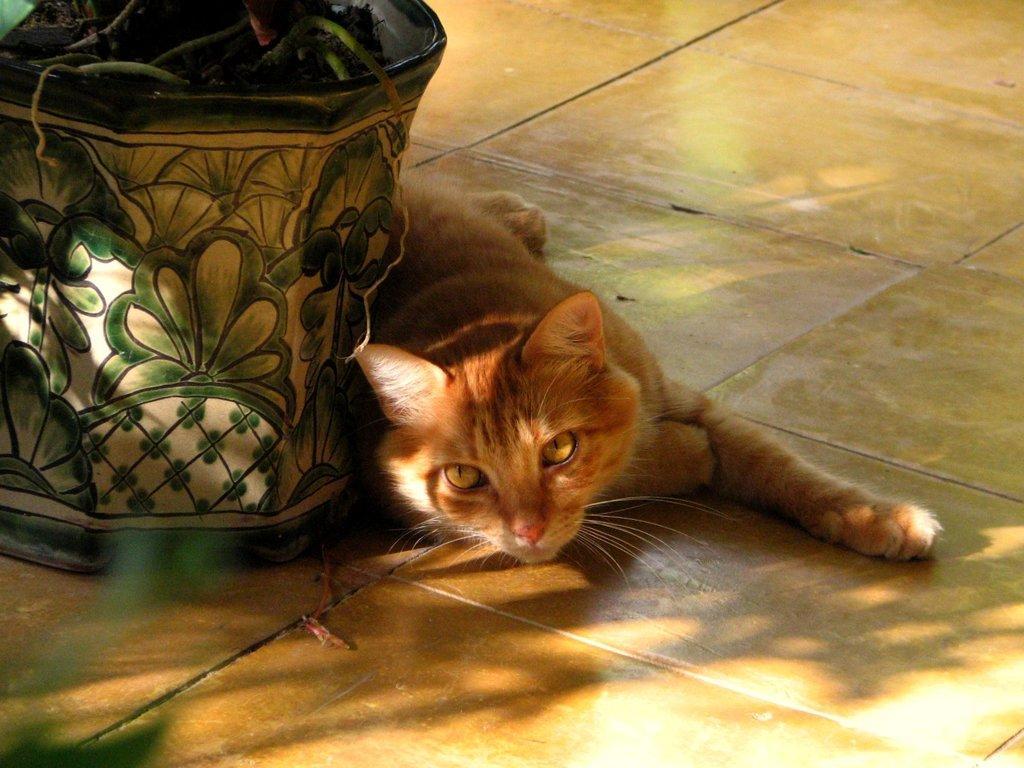Could you give a brief overview of what you see in this image? In the center of the image we can see a cat on the floor. We can also see a plant in a pot. 